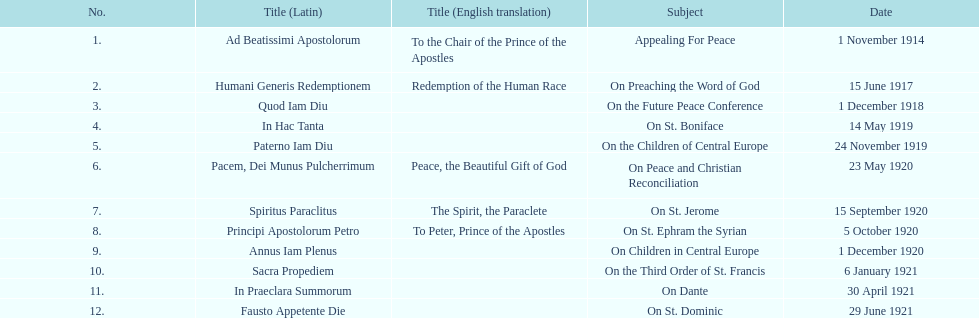After advocating for peace, what subject is discussed next? On Preaching the Word of God. 